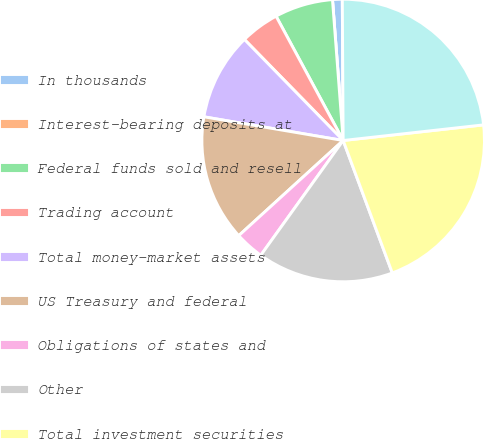Convert chart. <chart><loc_0><loc_0><loc_500><loc_500><pie_chart><fcel>In thousands<fcel>Interest-bearing deposits at<fcel>Federal funds sold and resell<fcel>Trading account<fcel>Total money-market assets<fcel>US Treasury and federal<fcel>Obligations of states and<fcel>Other<fcel>Total investment securities<fcel>Commercial financial leasing<nl><fcel>1.11%<fcel>0.0%<fcel>6.67%<fcel>4.44%<fcel>10.0%<fcel>14.44%<fcel>3.33%<fcel>15.56%<fcel>21.11%<fcel>23.33%<nl></chart> 